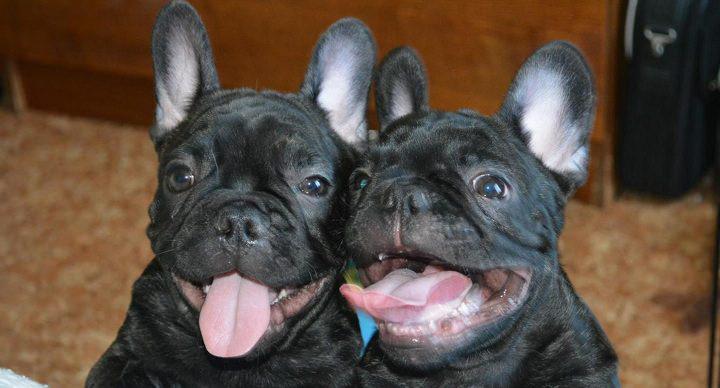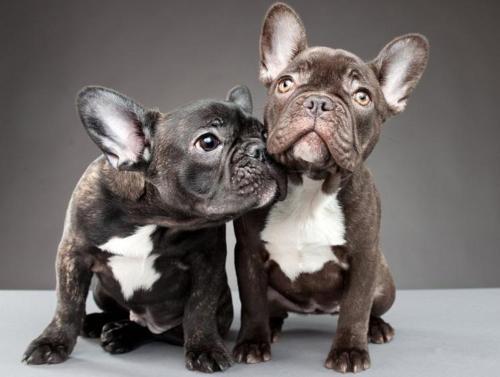The first image is the image on the left, the second image is the image on the right. Examine the images to the left and right. Is the description "An image shows two tan big-eared dogs posed alongside each other on a seat cushion with a burlap-like rough woven texture." accurate? Answer yes or no. No. The first image is the image on the left, the second image is the image on the right. Considering the images on both sides, is "There are two dogs with mouths open and tongue visible in the left image." valid? Answer yes or no. Yes. 